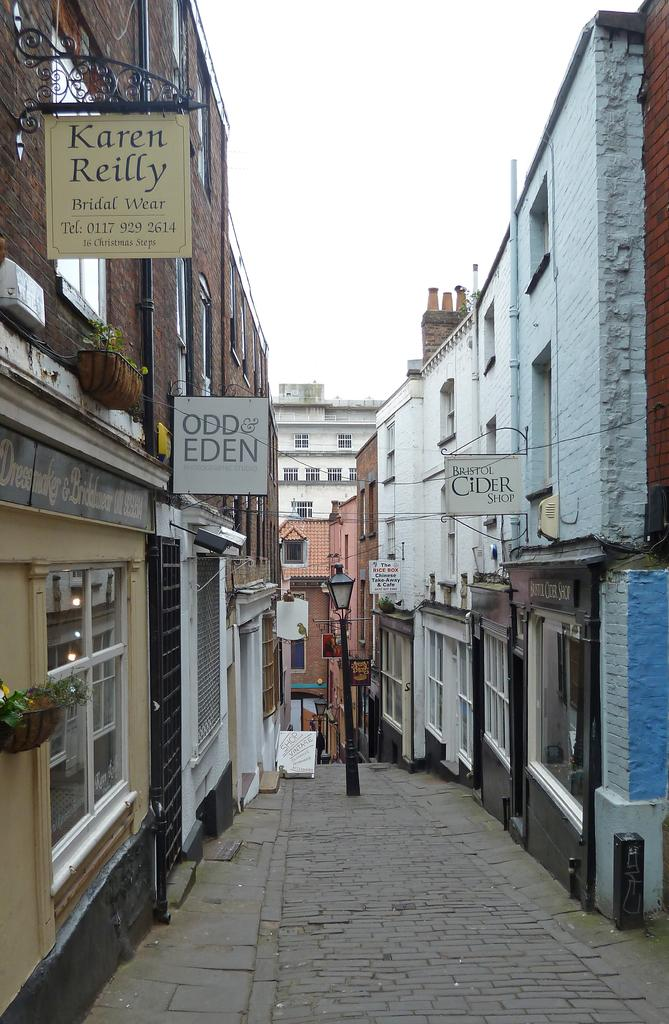What is the main setting of the image? The image appears to depict a street. What type of buildings can be seen on the left side of the image? There are buildings with glass windows on the left side of the image. What is attached to the buildings? There are boards visible on the buildings. What is visible at the top of the image? The sky is visible at the top of the image. What flavor of ice cream is being served to the group in the image? There is no group or ice cream present in the image; it depicts a street with buildings and boards. What is the plot of the story unfolding in the image? The image does not depict a story or plot; it is a depiction of a street with buildings and boards. 